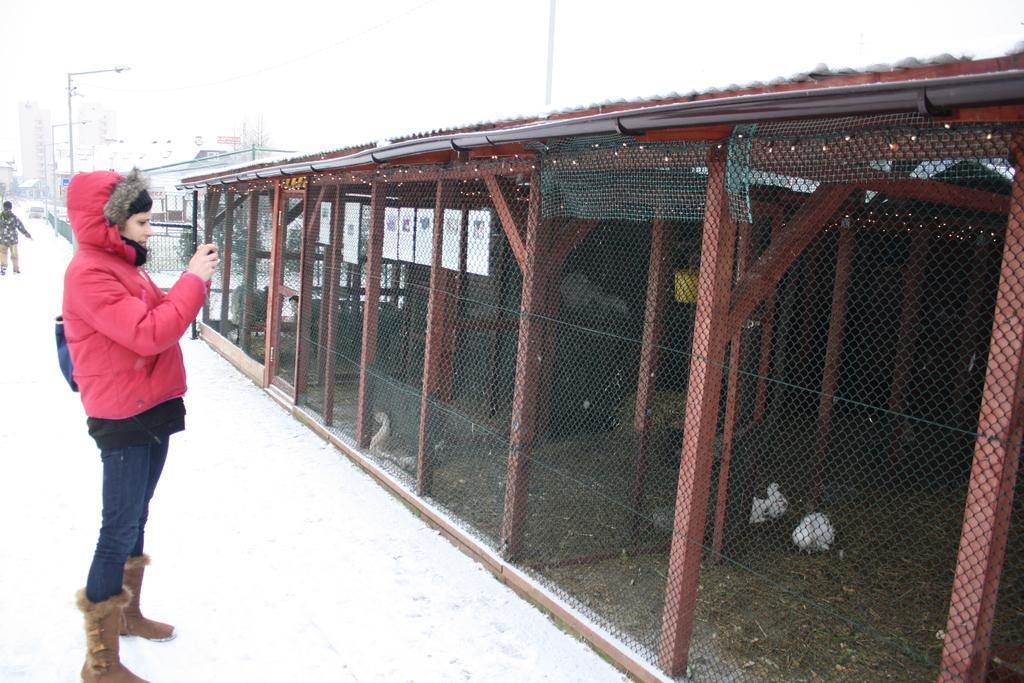Could you give a brief overview of what you see in this image? In this image in the front there is a woman standing and clicking a photo. On the right side there is a cage and there are birds in the cage and there is snow on the ground. In the background there are buildings, poles and there is a person visible. 